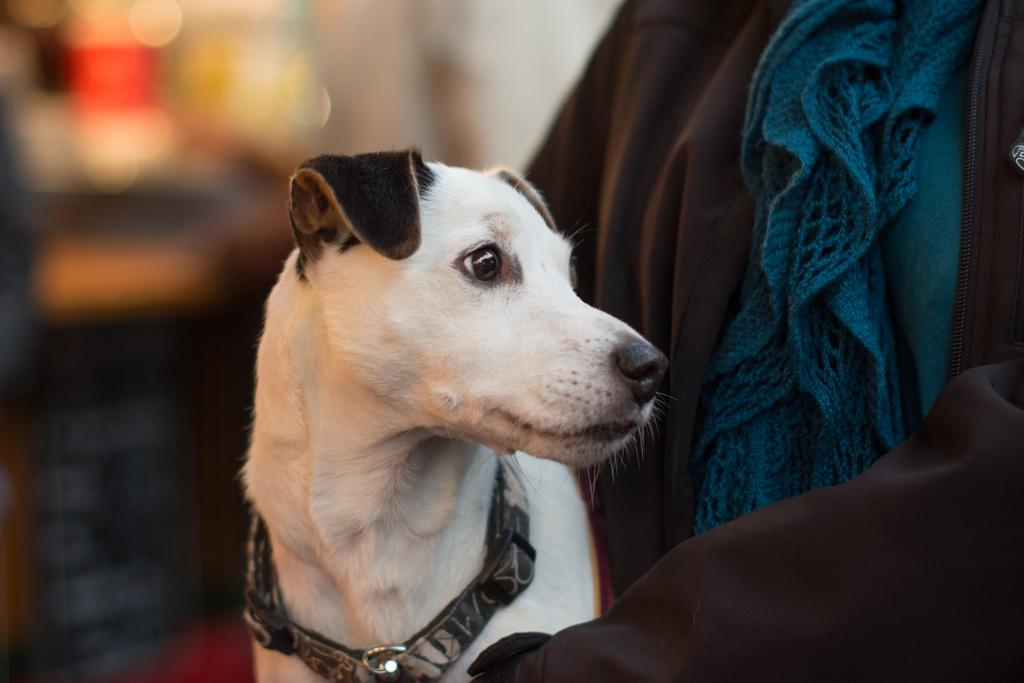What type of animal is in the image? There is a dog in the image. What is the dog wearing? The dog is wearing a belt. What type of material is visible in the image? There is cloth visible in the image. How would you describe the background of the image? The background of the image is blurry. What type of skin condition does the dog have in the image? There is no indication of a skin condition in the image; the dog appears to have normal fur. Can you tell me how many drawers are visible in the image? There are no drawers present in the image. What type of cannon is being fired in the image? There is no cannon present in the image. 